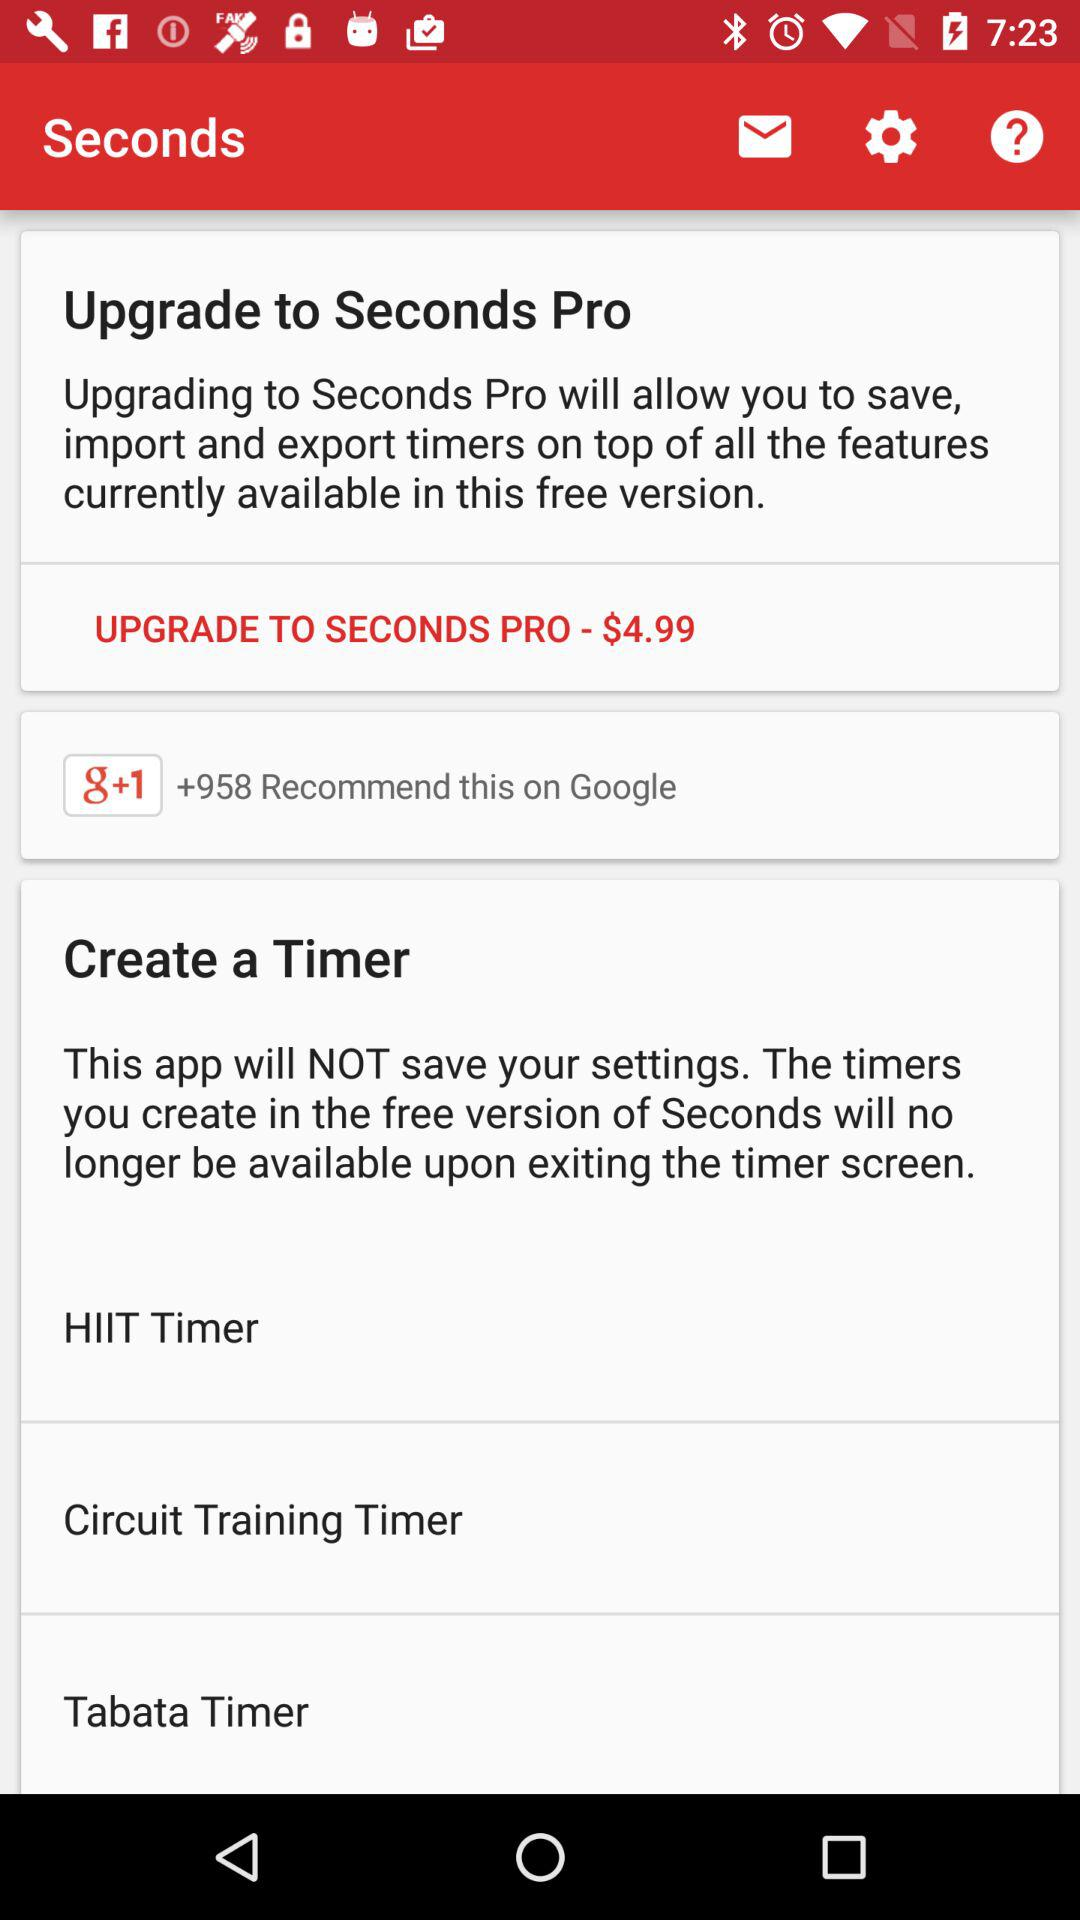What is the subscription price of the upgraded version? The subscription price of the upgraded version is $4.99. 